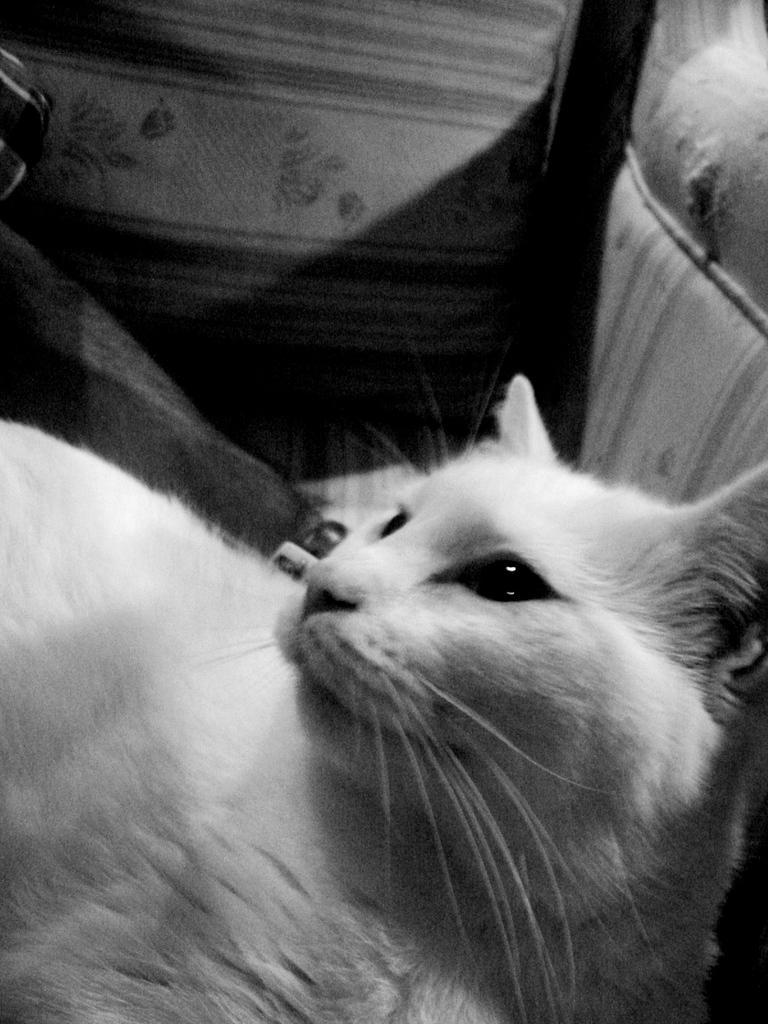Could you give a brief overview of what you see in this image? In this image we can see a cat which is in white color. 